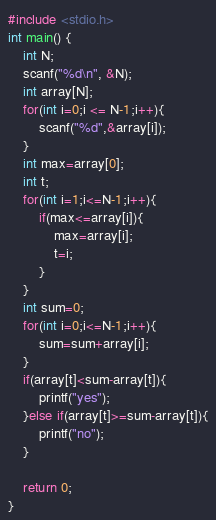Convert code to text. <code><loc_0><loc_0><loc_500><loc_500><_C_>#include <stdio.h>
int main() {
    int N;
    scanf("%d\n", &N);
    int array[N];
    for(int i=0;i <= N-1;i++){
        scanf("%d",&array[i]);
    }
    int max=array[0];
    int t;
    for(int i=1;i<=N-1;i++){
        if(max<=array[i]){
            max=array[i];
            t=i;
        }
    }
    int sum=0;
    for(int i=0;i<=N-1;i++){
        sum=sum+array[i];
    }
    if(array[t]<sum-array[t]){
        printf("yes");
    }else if(array[t]>=sum-array[t]){
        printf("no");
    }
 
    return 0;
}
</code> 